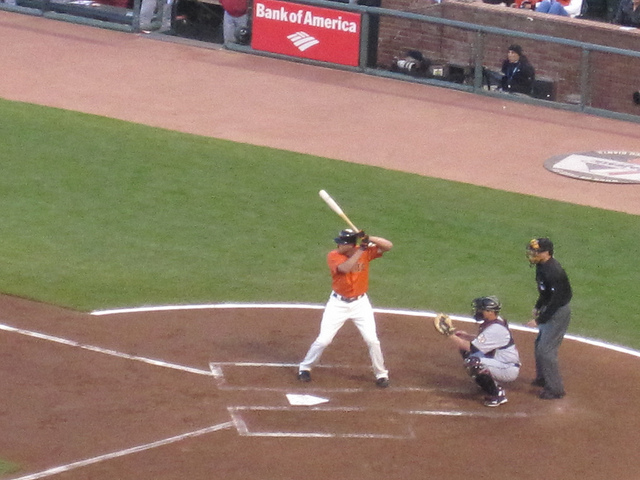<image>What teams are playing? It is unknown which teams are playing. They could be the Orioles and Mariners, Dodgers and Yankees, or Oriole and Red Sox. What teams are playing? I don't know what teams are playing. It can be seen 'orange team', 'orioles and mariners', 'chicago cubs', 'dodgers and yankees', 'orioles', or 'oriole and red sox'. 